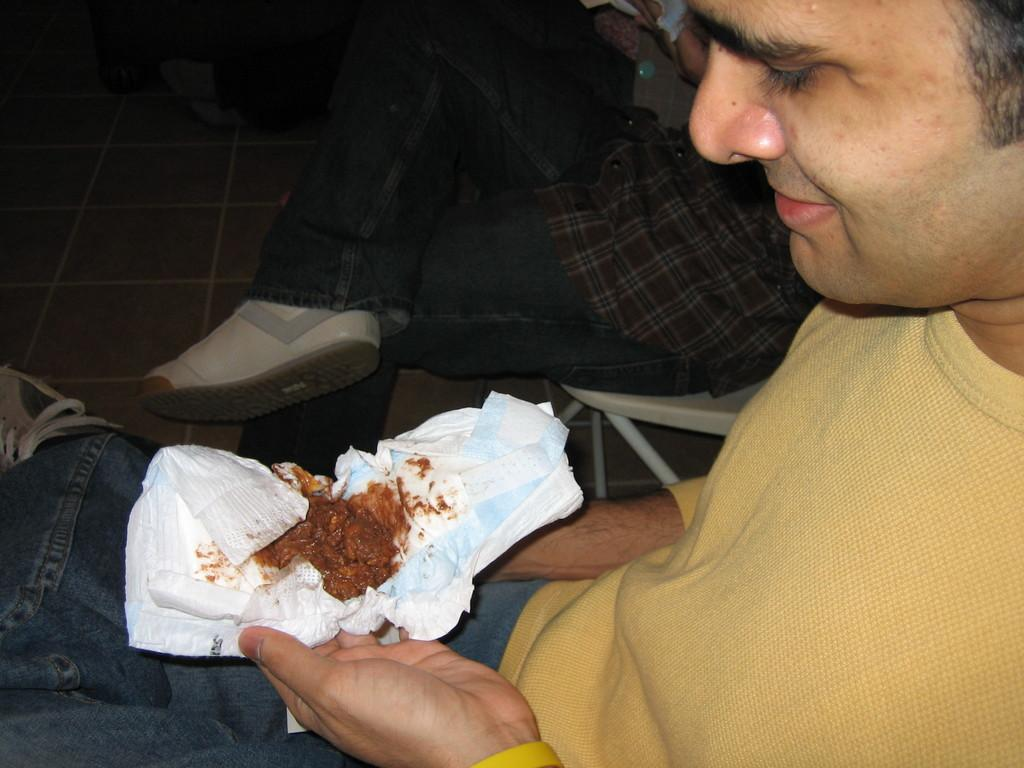Who is present in the image? There is a man in the image. What is the man holding in the image? The man is holding a diaper. Can you describe the other person in the image? There is another person sitting beside the man on a chair. What type of fork is being used to eat the meal in the image? There is no fork or meal present in the image. How many bubbles can be seen floating around the person sitting on the chair? There are no bubbles present in the image. 